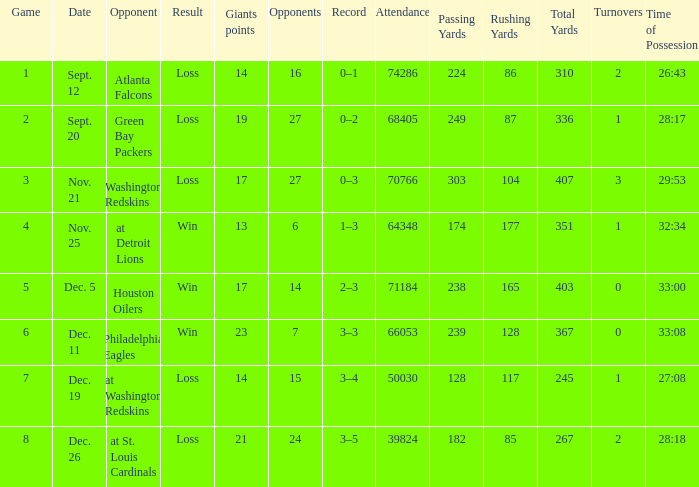What is the record when the opponent is washington redskins? 0–3. 